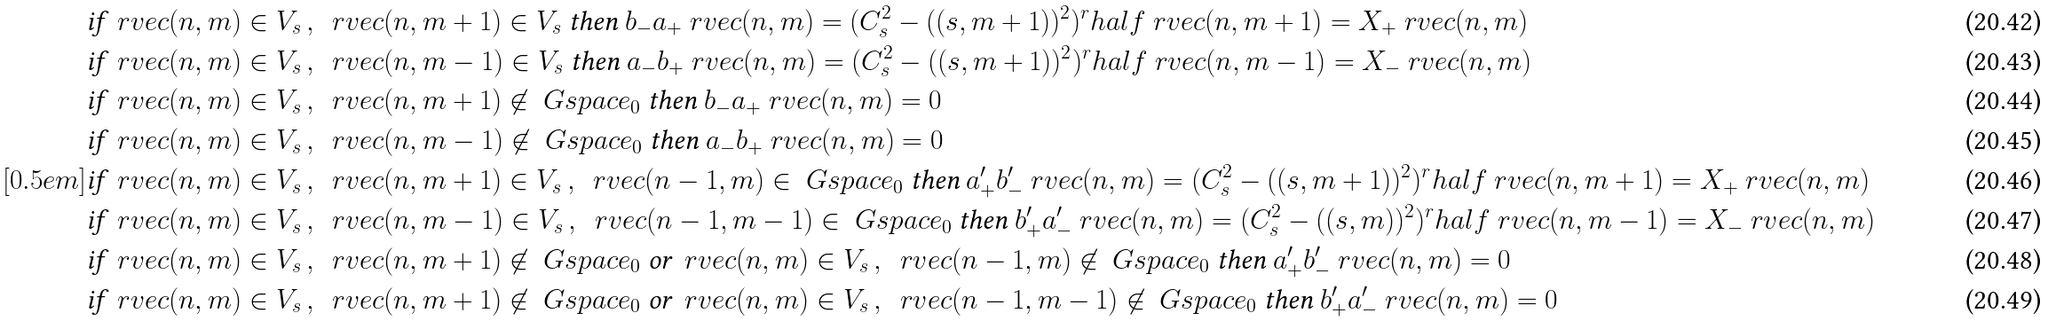<formula> <loc_0><loc_0><loc_500><loc_500>& \text {if } \ r v e c ( n , m ) \in V _ { s } \, , \ \ r v e c ( n , m + 1 ) \in V _ { s } \text { then } b _ { - } a _ { + } \ r v e c ( n , m ) = ( C _ { s } ^ { 2 } - ( ( s , m + 1 ) ) ^ { 2 } ) ^ { r } h a l f \ r v e c ( n , m + 1 ) = X _ { + } \ r v e c ( n , m ) \\ & \text {if } \ r v e c ( n , m ) \in V _ { s } \, , \ \ r v e c ( n , m - 1 ) \in V _ { s } \text { then } a _ { - } b _ { + } \ r v e c ( n , m ) = ( C _ { s } ^ { 2 } - ( ( s , m + 1 ) ) ^ { 2 } ) ^ { r } h a l f \ r v e c ( n , m - 1 ) = X _ { - } \ r v e c ( n , m ) \\ & \text {if } \ r v e c ( n , m ) \in V _ { s } \, , \ \ r v e c ( n , m + 1 ) \not \in \ G s p a c e _ { 0 } \text { then } b _ { - } a _ { + } \ r v e c ( n , m ) = 0 \\ & \text {if } \ r v e c ( n , m ) \in V _ { s } \, , \ \ r v e c ( n , m - 1 ) \not \in \ G s p a c e _ { 0 } \text { then } a _ { - } b _ { + } \ r v e c ( n , m ) = 0 \\ [ 0 . 5 e m ] & \text {if } \ r v e c ( n , m ) \in V _ { s } \, , \ \ r v e c ( n , m + 1 ) \in V _ { s } \, , \ \ r v e c ( n - 1 , m ) \in \ G s p a c e _ { 0 } \text { then } a ^ { \prime } _ { + } b ^ { \prime } _ { - } \ r v e c ( n , m ) = ( C _ { s } ^ { 2 } - ( ( s , m + 1 ) ) ^ { 2 } ) ^ { r } h a l f \ r v e c ( n , m + 1 ) = X _ { + } \ r v e c ( n , m ) \\ & \text {if } \ r v e c ( n , m ) \in V _ { s } \, , \ \ r v e c ( n , m - 1 ) \in V _ { s } \, , \ \ r v e c ( n - 1 , m - 1 ) \in \ G s p a c e _ { 0 } \text { then } b ^ { \prime } _ { + } a ^ { \prime } _ { - } \ r v e c ( n , m ) = ( C _ { s } ^ { 2 } - ( ( s , m ) ) ^ { 2 } ) ^ { r } h a l f \ r v e c ( n , m - 1 ) = X _ { - } \ r v e c ( n , m ) \\ & \text {if } \ r v e c ( n , m ) \in V _ { s } \, , \ \ r v e c ( n , m + 1 ) \not \in \ G s p a c e _ { 0 } \text { or } \ r v e c ( n , m ) \in V _ { s } \, , \ \ r v e c ( n - 1 , m ) \not \in \ G s p a c e _ { 0 } \text { then } a ^ { \prime } _ { + } b ^ { \prime } _ { - } \ r v e c ( n , m ) = 0 \\ & \text {if } \ r v e c ( n , m ) \in V _ { s } \, , \ \ r v e c ( n , m + 1 ) \not \in \ G s p a c e _ { 0 } \text { or } \ r v e c ( n , m ) \in V _ { s } \, , \ \ r v e c ( n - 1 , m - 1 ) \not \in \ G s p a c e _ { 0 } \text { then } b ^ { \prime } _ { + } a ^ { \prime } _ { - } \ r v e c ( n , m ) = 0</formula> 